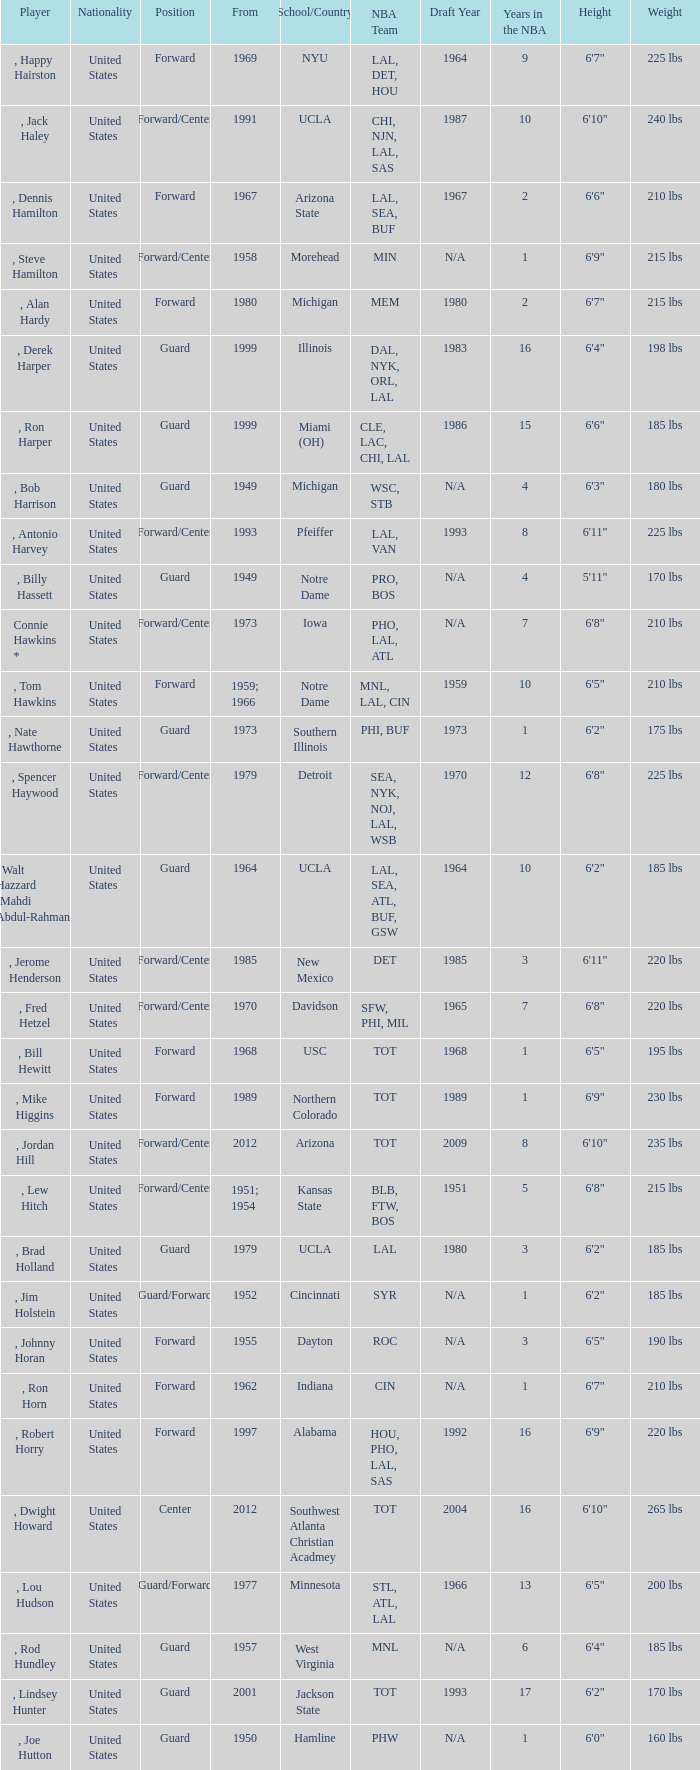Which school has the player that started in 1958? Morehead. 